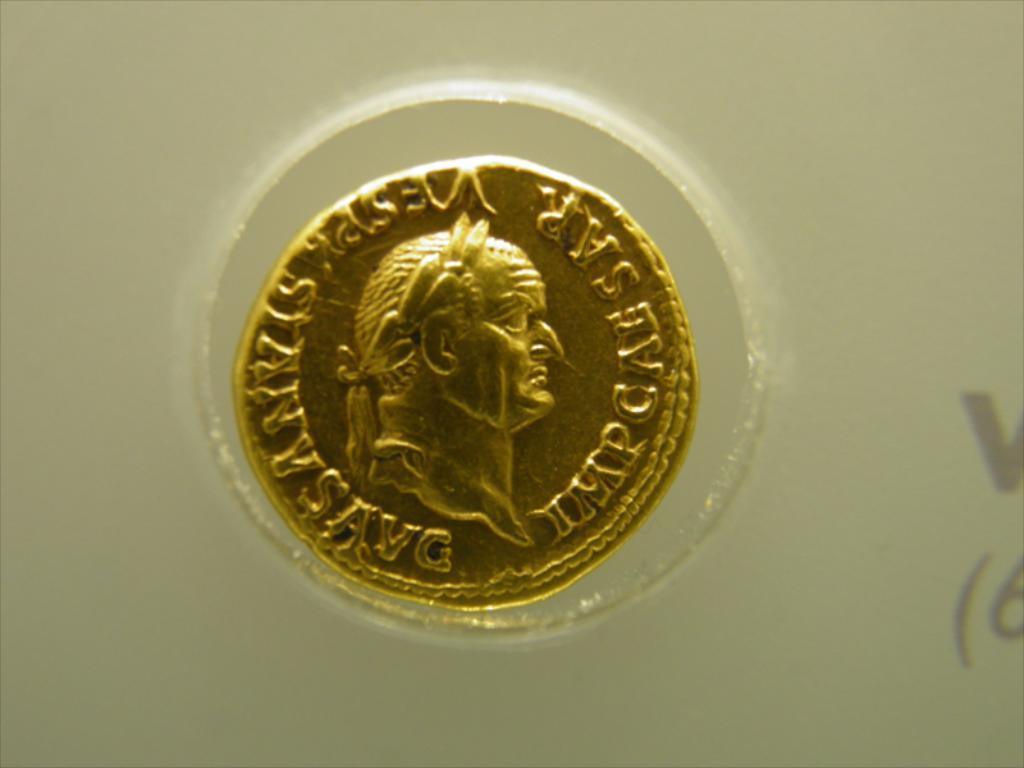<image>
Give a short and clear explanation of the subsequent image. A gold coin has letters on it including IMP at the bottom right. 